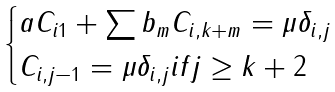<formula> <loc_0><loc_0><loc_500><loc_500>\begin{cases} a C _ { i 1 } + \sum b _ { m } C _ { i , k + m } = \mu \delta _ { i , j } \\ C _ { i , j - 1 } = \mu \delta _ { i , j } i f j \geq k + 2 \end{cases}</formula> 